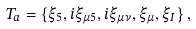Convert formula to latex. <formula><loc_0><loc_0><loc_500><loc_500>T _ { a } = \{ \xi _ { 5 } , i \xi _ { \mu 5 } , i \xi _ { \mu \nu } , \xi _ { \mu } , \xi _ { I } \} \, ,</formula> 